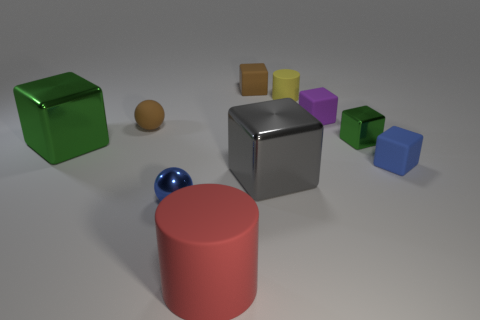Subtract all green cubes. How many cubes are left? 4 Subtract all tiny metallic blocks. How many blocks are left? 5 Subtract all red blocks. Subtract all red balls. How many blocks are left? 6 Subtract all cubes. How many objects are left? 4 Add 4 tiny green shiny things. How many tiny green shiny things exist? 5 Subtract 2 green blocks. How many objects are left? 8 Subtract all small metallic blocks. Subtract all large red matte cylinders. How many objects are left? 8 Add 5 gray things. How many gray things are left? 6 